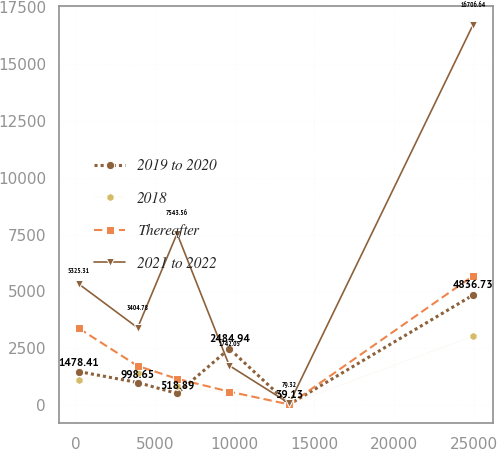Convert chart. <chart><loc_0><loc_0><loc_500><loc_500><line_chart><ecel><fcel>2019 to 2020<fcel>2018<fcel>Thereafter<fcel>2021 to 2022<nl><fcel>203.62<fcel>1478.41<fcel>1125.02<fcel>3377.98<fcel>5325.31<nl><fcel>3895.63<fcel>998.65<fcel>1423.31<fcel>1727.27<fcel>3404.78<nl><fcel>6370.75<fcel>518.89<fcel>826.73<fcel>1162.74<fcel>7543.56<nl><fcel>9652.68<fcel>2484.94<fcel>528.44<fcel>598.21<fcel>1742.05<nl><fcel>13422<fcel>39.13<fcel>52.07<fcel>33.68<fcel>79.32<nl><fcel>24954.8<fcel>4836.73<fcel>3034.97<fcel>5679.01<fcel>16706.6<nl></chart> 